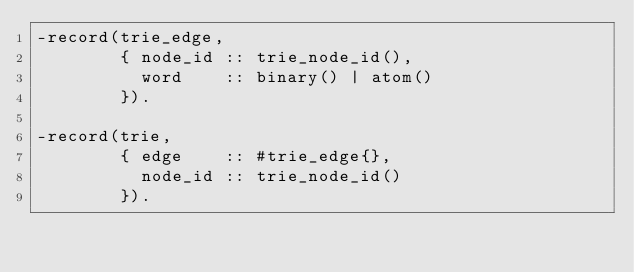<code> <loc_0><loc_0><loc_500><loc_500><_Erlang_>-record(trie_edge,
        { node_id :: trie_node_id(),
          word    :: binary() | atom()
        }).

-record(trie,
        { edge    :: #trie_edge{},
          node_id :: trie_node_id()
        }).

</code> 